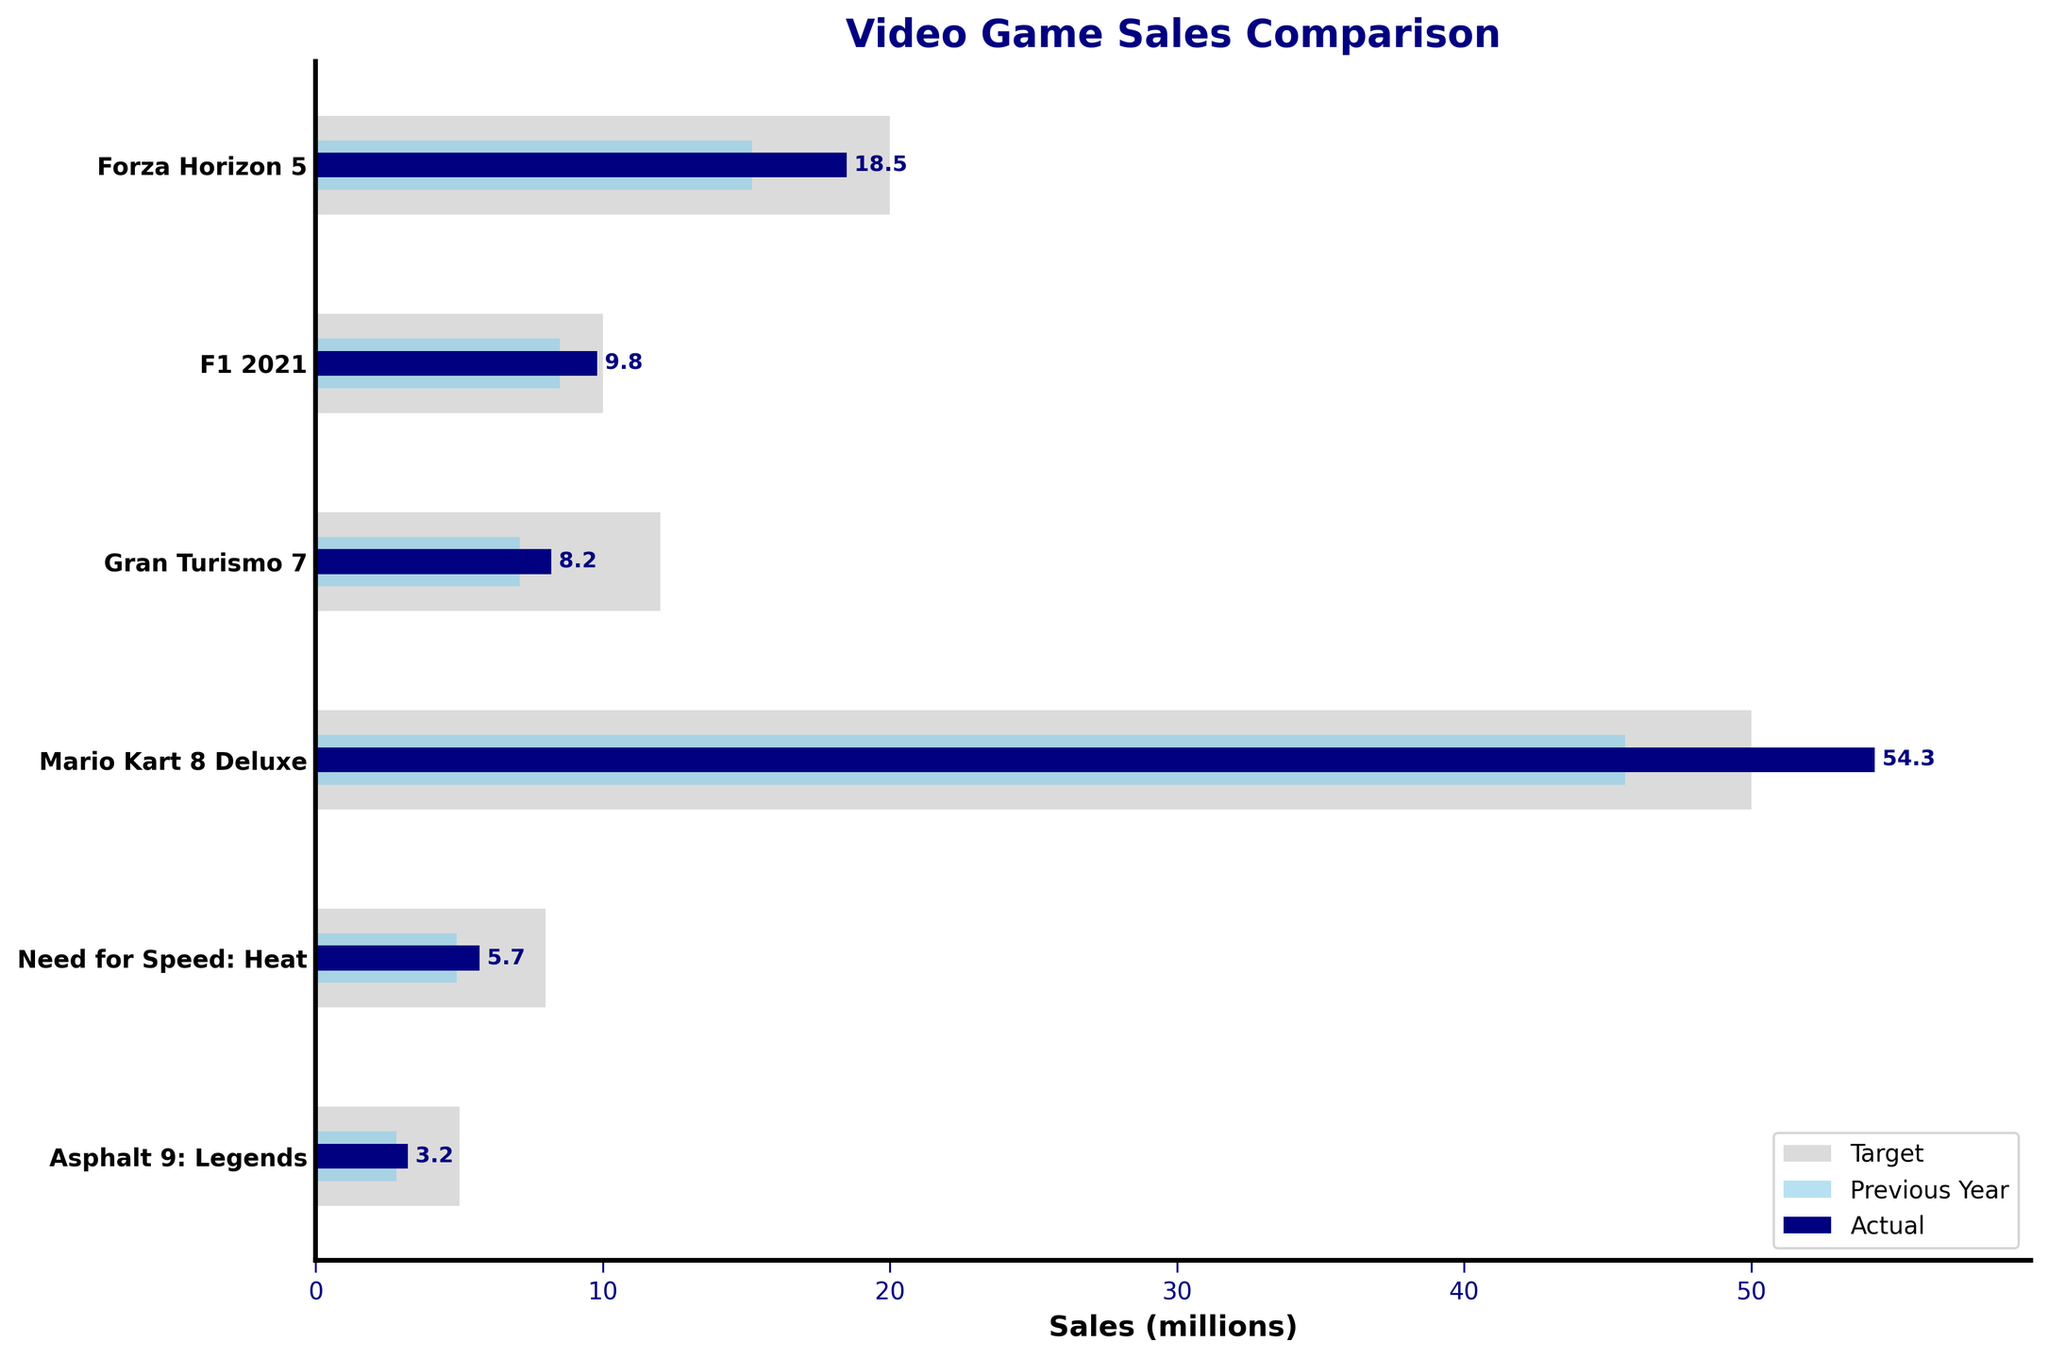What is the title of the chart? The title is usually the text that describes what the chart is about. It's located above the plot. By looking at the chart, you'll see the bold text at the top, which is the title.
Answer: Video Game Sales Comparison Which game had the highest actual sales? The actual sales are represented by the darkest bars (navy). By comparing the length of all the navy bars, the longest one can be identified as pointing to the highest actual sales.
Answer: Mario Kart 8 Deluxe What are the target sales for F1 2021? The target sales are shown by the light grey bars. Find the light grey bar corresponding to F1 2021 and read the value along the x-axis.
Answer: 10 million Which game exceeded its target sales the most? To determine this, we need to compare the actual sales (dark navy bars) to the target sales (light grey bars) for each game. The game with the longest navy bar surpassing its respective grey bar the most is the answer.
Answer: Mario Kart 8 Deluxe How much did Gran Turismo 7 fall short of its target sales? Find the difference between the target sales (light grey bars) and actual sales (navy bars) for Gran Turismo 7. Subtract the actual sales from the target sales.
Answer: 3.8 million Which game had the smallest increase in sales compared to the previous year? Compare all previous year sales (skyblue bars) with the actual sales (navy bars) and determine the smallest difference.
Answer: Asphalt 9: Legends How many games failed to meet their target sales? Count the number of games where the actual sales (navy bars) are less than the target sales (light grey bars).
Answer: 4 Which game saw the highest increase in sales compared to the previous year? Identify the game with the biggest difference between actual sales (navy bars) and previous year sales (skyblue bars).
Answer: Mario Kart 8 Deluxe What is the combined actual sales of the top three games in terms of actual sales? Identify the top three games with the highest navy bars and sum their actual sales figures. Mario Kart 8 Deluxe (54.3) + Forza Horizon 5 (18.5) + F1 2021 (9.8).
Answer: 82.6 million 